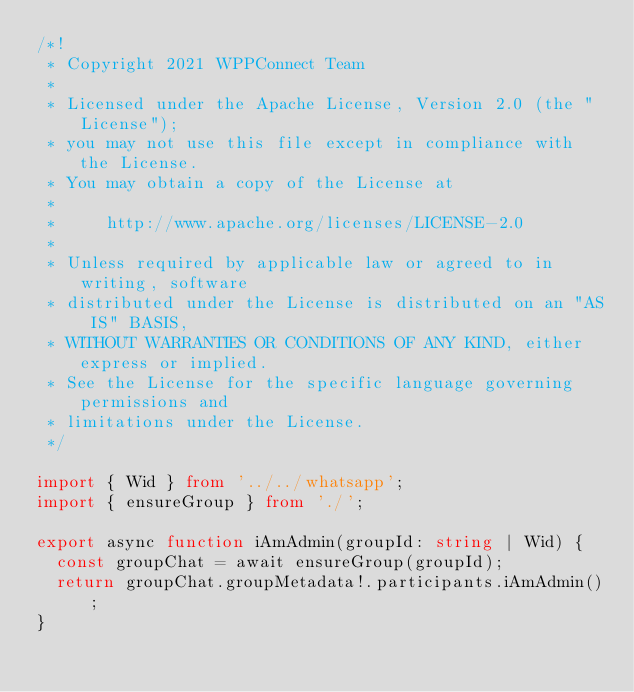<code> <loc_0><loc_0><loc_500><loc_500><_TypeScript_>/*!
 * Copyright 2021 WPPConnect Team
 *
 * Licensed under the Apache License, Version 2.0 (the "License");
 * you may not use this file except in compliance with the License.
 * You may obtain a copy of the License at
 *
 *     http://www.apache.org/licenses/LICENSE-2.0
 *
 * Unless required by applicable law or agreed to in writing, software
 * distributed under the License is distributed on an "AS IS" BASIS,
 * WITHOUT WARRANTIES OR CONDITIONS OF ANY KIND, either express or implied.
 * See the License for the specific language governing permissions and
 * limitations under the License.
 */

import { Wid } from '../../whatsapp';
import { ensureGroup } from './';

export async function iAmAdmin(groupId: string | Wid) {
  const groupChat = await ensureGroup(groupId);
  return groupChat.groupMetadata!.participants.iAmAdmin();
}
</code> 